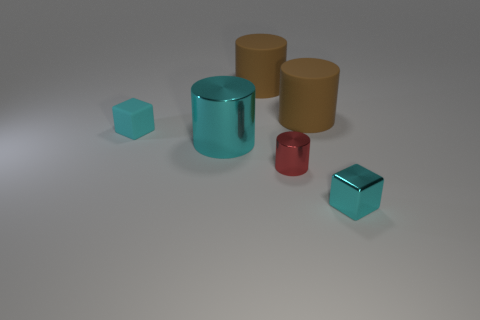Considering the arrangement of the objects, could there be a functional relationship between them? While the purpose of these objects is not clear from the image alone, their positioning might imply a study in contrasts—contrasting shapes (cylinders vs cubes), materials (rubber vs metal), and colors (cyan vs red and yellow). This could be a deliberate setup for a visual experiment or simply an aesthetic choice for the viewer to consider the interplay of these elements. 